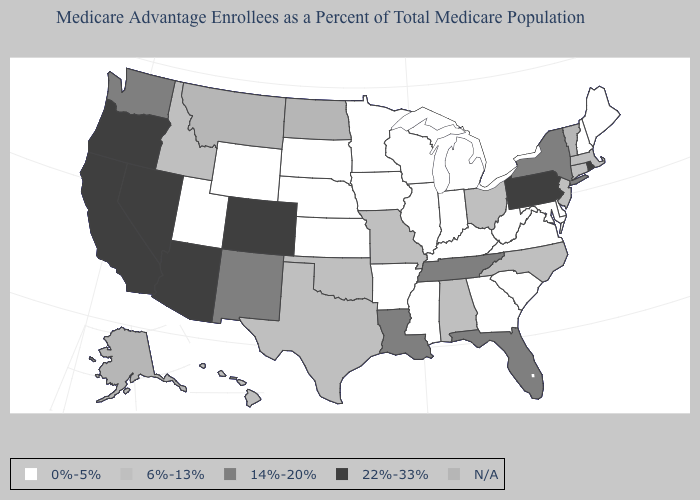Among the states that border Minnesota , which have the lowest value?
Answer briefly. Iowa, South Dakota, Wisconsin. Does the map have missing data?
Give a very brief answer. Yes. Which states hav the highest value in the MidWest?
Give a very brief answer. Missouri, Ohio. Which states have the lowest value in the West?
Short answer required. Utah, Wyoming. What is the lowest value in the South?
Write a very short answer. 0%-5%. Among the states that border West Virginia , which have the highest value?
Be succinct. Pennsylvania. Name the states that have a value in the range N/A?
Be succinct. Alaska, Montana, North Dakota, Vermont. Among the states that border Arkansas , which have the highest value?
Short answer required. Louisiana, Tennessee. Which states hav the highest value in the South?
Be succinct. Florida, Louisiana, Tennessee. What is the lowest value in the MidWest?
Short answer required. 0%-5%. What is the value of Florida?
Short answer required. 14%-20%. What is the value of Tennessee?
Give a very brief answer. 14%-20%. Which states hav the highest value in the West?
Keep it brief. Arizona, California, Colorado, Nevada, Oregon. What is the value of Mississippi?
Short answer required. 0%-5%. 